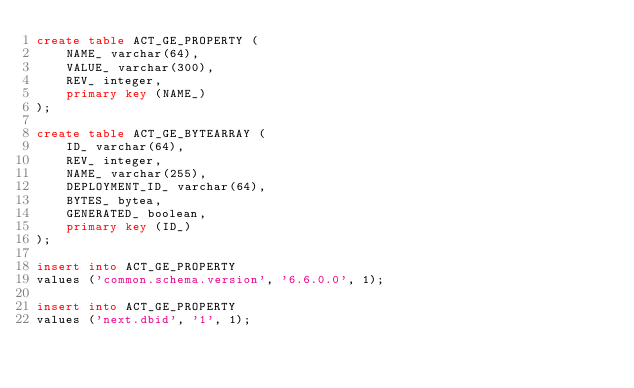Convert code to text. <code><loc_0><loc_0><loc_500><loc_500><_SQL_>create table ACT_GE_PROPERTY (
    NAME_ varchar(64),
    VALUE_ varchar(300),
    REV_ integer,
    primary key (NAME_)
);

create table ACT_GE_BYTEARRAY (
    ID_ varchar(64),
    REV_ integer,
    NAME_ varchar(255),
    DEPLOYMENT_ID_ varchar(64),
    BYTES_ bytea,
    GENERATED_ boolean,
    primary key (ID_)
);

insert into ACT_GE_PROPERTY
values ('common.schema.version', '6.6.0.0', 1);

insert into ACT_GE_PROPERTY
values ('next.dbid', '1', 1);
</code> 